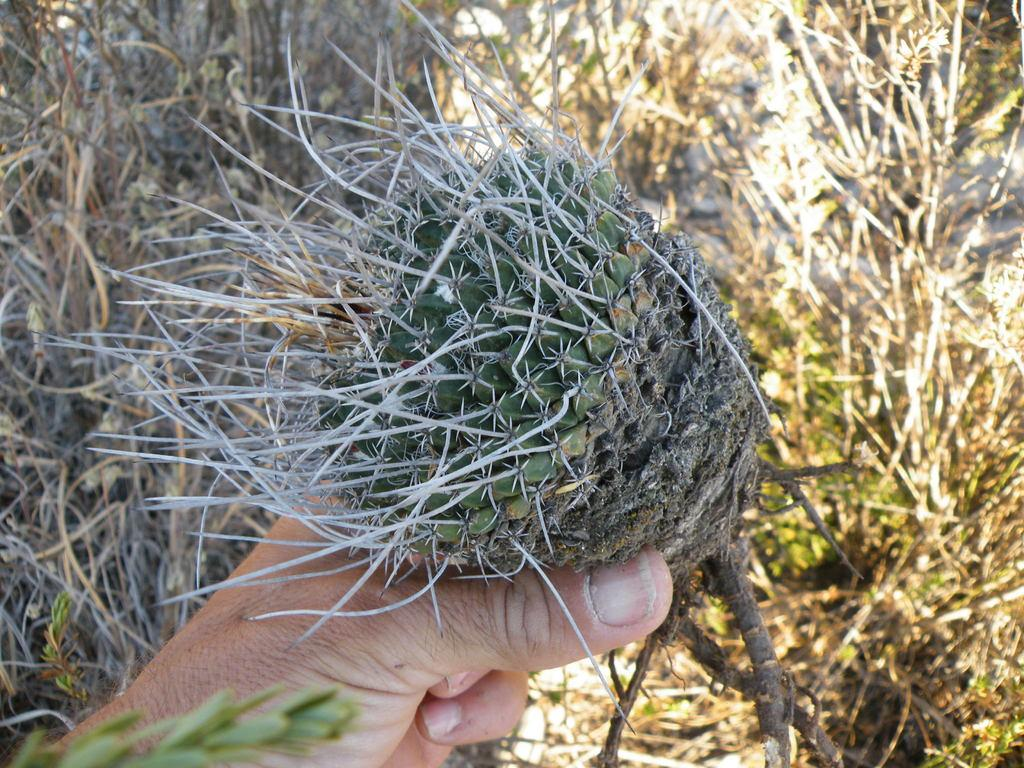What is located in the foreground of the image? There is a plant in the foreground of the image. Who is interacting with the plant in the image? A person is holding the plant in the image. What can be seen in the background of the image? In the background, there appear to be plants. What force is being applied to the plant by the person in the image? There is no indication of force being applied to the plant by the person in the image; the person is simply holding it. Is there a fire visible in the image? No, there is no fire present in the image. 